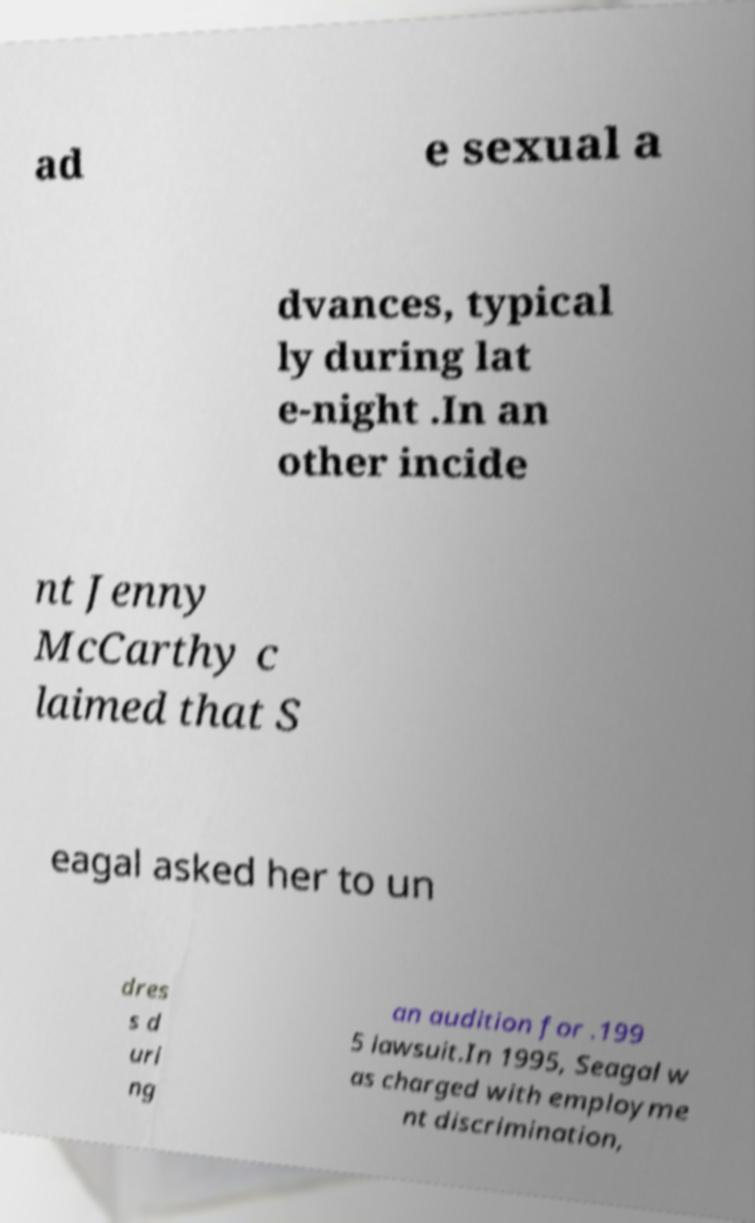For documentation purposes, I need the text within this image transcribed. Could you provide that? ad e sexual a dvances, typical ly during lat e-night .In an other incide nt Jenny McCarthy c laimed that S eagal asked her to un dres s d uri ng an audition for .199 5 lawsuit.In 1995, Seagal w as charged with employme nt discrimination, 